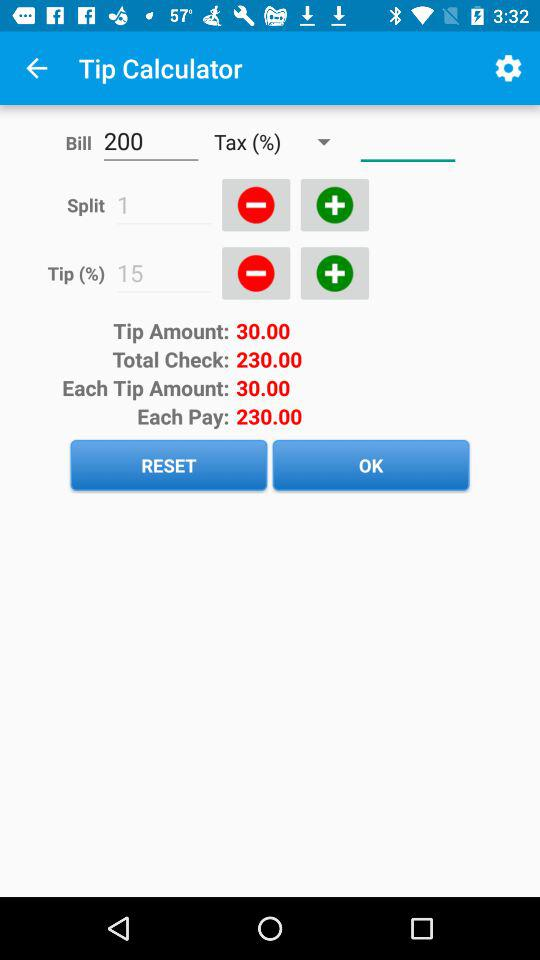What is the amount of the bill? The amount is 200. 